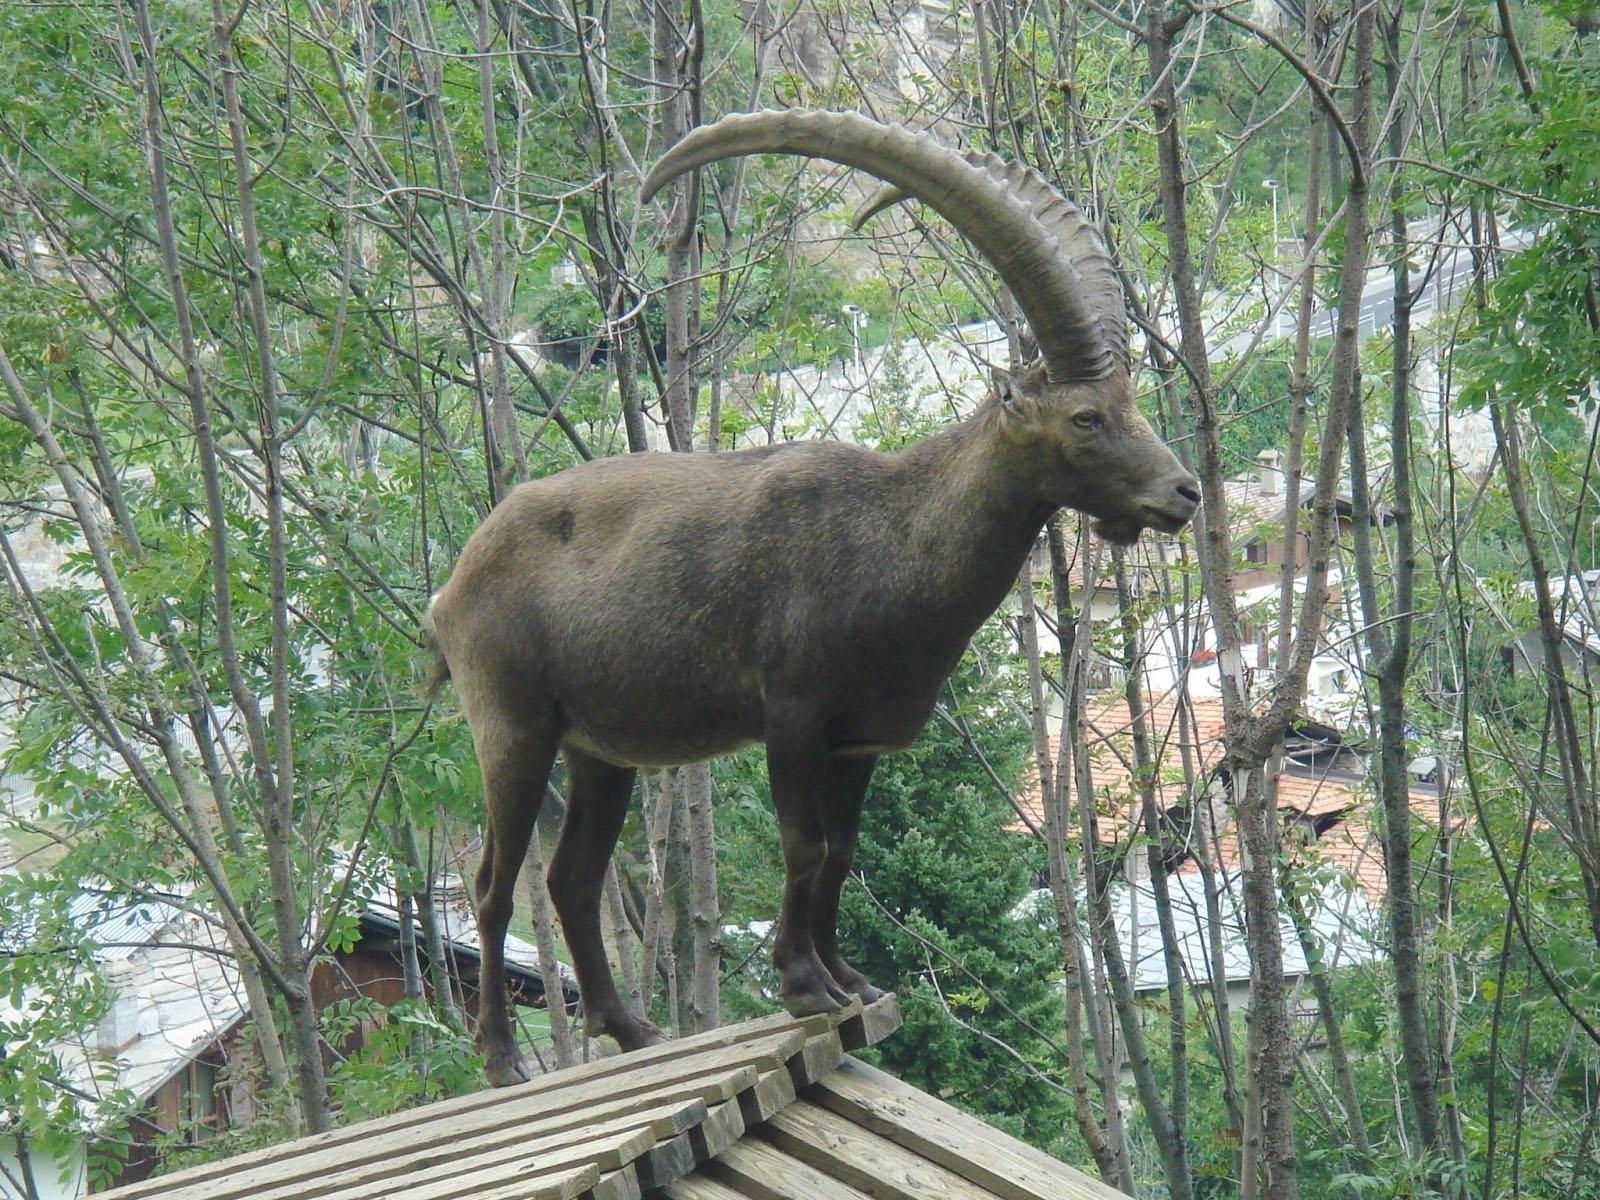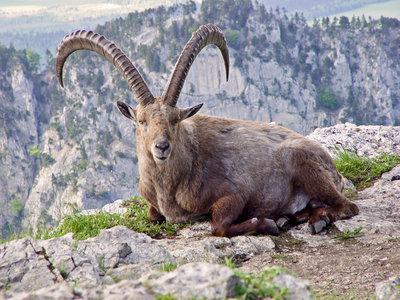The first image is the image on the left, the second image is the image on the right. For the images displayed, is the sentence "One animal with curved horns is laying on the ground and one animal is standing at the peak of something." factually correct? Answer yes or no. Yes. 